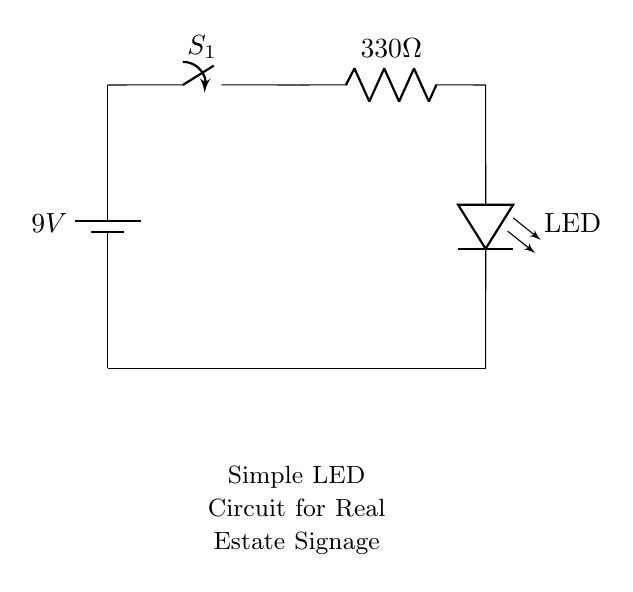What is the voltage of the battery? The battery in the circuit is labeled with a voltage of 9 volts, which indicates the electrical potential difference available for the circuit.
Answer: 9 volts What type of switch is used in this circuit? The circuit diagram identifies the component labeled as $S_1$ as a switch, suggesting it is a simple on/off switch that controls the flow of current.
Answer: Switch What is the resistance value of the resistor? The resistor in the circuit is labeled with a value of 330 ohms, which indicates its opposition to current flow, affecting the overall circuit behavior.
Answer: 330 ohms How many LEDs are present in this circuit? The diagram shows one LED component labeled "LED," indicating that there is only a single light-emitting diode integrated into the circuit to produce light.
Answer: One What happens to the LED when the switch is closed? When the switch $S_1$ is closed, current flows from the battery through the resistor and LED, resulting in the LED illuminating due to the passage of electric current.
Answer: Illuminates What is the purpose of the resistor in this circuit? The resistor limits the current flowing through the LED to prevent it from drawing excessive current, which can lead to damage or burnout, thereby ensuring safe operation.
Answer: Current limiting 